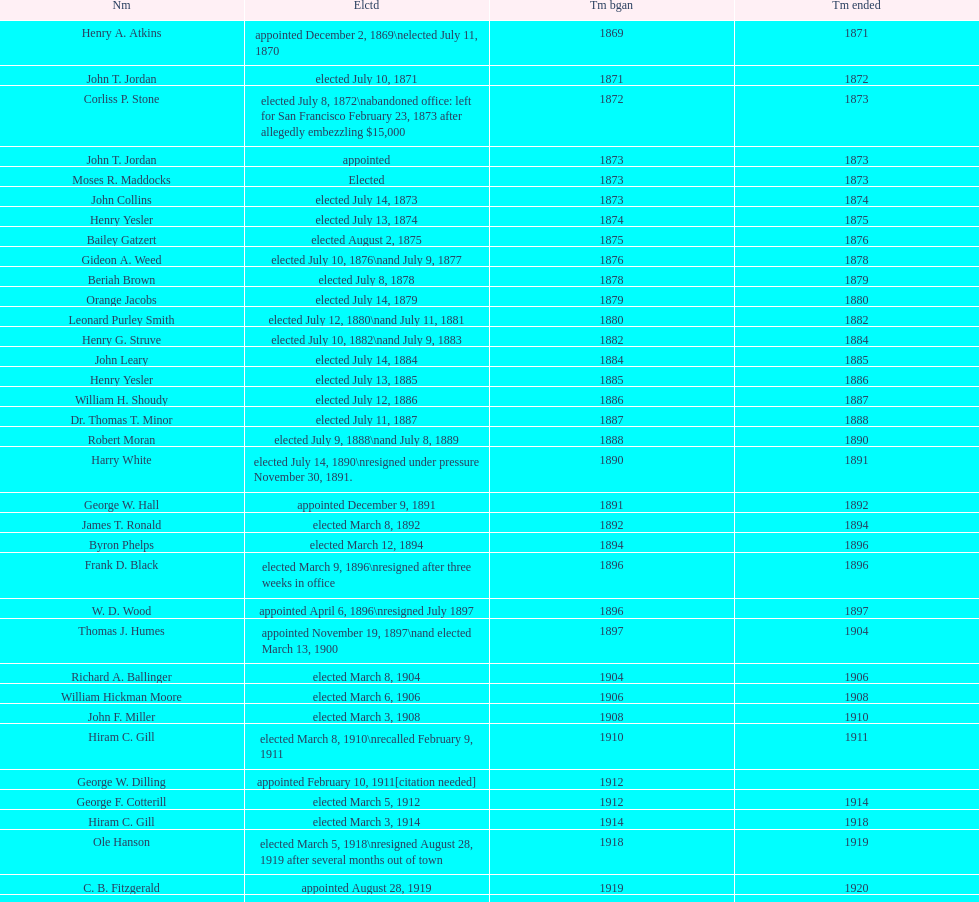Which mayor seattle, washington resigned after only three weeks in office in 1896? Frank D. Black. Give me the full table as a dictionary. {'header': ['Nm', 'Elctd', 'Tm bgan', 'Tm ended'], 'rows': [['Henry A. Atkins', 'appointed December 2, 1869\\nelected July 11, 1870', '1869', '1871'], ['John T. Jordan', 'elected July 10, 1871', '1871', '1872'], ['Corliss P. Stone', 'elected July 8, 1872\\nabandoned office: left for San Francisco February 23, 1873 after allegedly embezzling $15,000', '1872', '1873'], ['John T. Jordan', 'appointed', '1873', '1873'], ['Moses R. Maddocks', 'Elected', '1873', '1873'], ['John Collins', 'elected July 14, 1873', '1873', '1874'], ['Henry Yesler', 'elected July 13, 1874', '1874', '1875'], ['Bailey Gatzert', 'elected August 2, 1875', '1875', '1876'], ['Gideon A. Weed', 'elected July 10, 1876\\nand July 9, 1877', '1876', '1878'], ['Beriah Brown', 'elected July 8, 1878', '1878', '1879'], ['Orange Jacobs', 'elected July 14, 1879', '1879', '1880'], ['Leonard Purley Smith', 'elected July 12, 1880\\nand July 11, 1881', '1880', '1882'], ['Henry G. Struve', 'elected July 10, 1882\\nand July 9, 1883', '1882', '1884'], ['John Leary', 'elected July 14, 1884', '1884', '1885'], ['Henry Yesler', 'elected July 13, 1885', '1885', '1886'], ['William H. Shoudy', 'elected July 12, 1886', '1886', '1887'], ['Dr. Thomas T. Minor', 'elected July 11, 1887', '1887', '1888'], ['Robert Moran', 'elected July 9, 1888\\nand July 8, 1889', '1888', '1890'], ['Harry White', 'elected July 14, 1890\\nresigned under pressure November 30, 1891.', '1890', '1891'], ['George W. Hall', 'appointed December 9, 1891', '1891', '1892'], ['James T. Ronald', 'elected March 8, 1892', '1892', '1894'], ['Byron Phelps', 'elected March 12, 1894', '1894', '1896'], ['Frank D. Black', 'elected March 9, 1896\\nresigned after three weeks in office', '1896', '1896'], ['W. D. Wood', 'appointed April 6, 1896\\nresigned July 1897', '1896', '1897'], ['Thomas J. Humes', 'appointed November 19, 1897\\nand elected March 13, 1900', '1897', '1904'], ['Richard A. Ballinger', 'elected March 8, 1904', '1904', '1906'], ['William Hickman Moore', 'elected March 6, 1906', '1906', '1908'], ['John F. Miller', 'elected March 3, 1908', '1908', '1910'], ['Hiram C. Gill', 'elected March 8, 1910\\nrecalled February 9, 1911', '1910', '1911'], ['George W. Dilling', 'appointed February 10, 1911[citation needed]', '1912', ''], ['George F. Cotterill', 'elected March 5, 1912', '1912', '1914'], ['Hiram C. Gill', 'elected March 3, 1914', '1914', '1918'], ['Ole Hanson', 'elected March 5, 1918\\nresigned August 28, 1919 after several months out of town', '1918', '1919'], ['C. B. Fitzgerald', 'appointed August 28, 1919', '1919', '1920'], ['Hugh M. Caldwell', 'elected March 2, 1920', '1920', '1922'], ['Edwin J. Brown', 'elected May 2, 1922\\nand March 4, 1924', '1922', '1926'], ['Bertha Knight Landes', 'elected March 9, 1926', '1926', '1928'], ['Frank E. Edwards', 'elected March 6, 1928\\nand March 4, 1930\\nrecalled July 13, 1931', '1928', '1931'], ['Robert H. Harlin', 'appointed July 14, 1931', '1931', '1932'], ['John F. Dore', 'elected March 8, 1932', '1932', '1934'], ['Charles L. Smith', 'elected March 6, 1934', '1934', '1936'], ['John F. Dore', 'elected March 3, 1936\\nbecame gravely ill and was relieved of office April 13, 1938, already a lame duck after the 1938 election. He died five days later.', '1936', '1938'], ['Arthur B. Langlie', "elected March 8, 1938\\nappointed to take office early, April 27, 1938, after Dore's death.\\nelected March 5, 1940\\nresigned January 11, 1941, to become Governor of Washington", '1938', '1941'], ['John E. Carroll', 'appointed January 27, 1941', '1941', '1941'], ['Earl Millikin', 'elected March 4, 1941', '1941', '1942'], ['William F. Devin', 'elected March 3, 1942, March 7, 1944, March 5, 1946, and March 2, 1948', '1942', '1952'], ['Allan Pomeroy', 'elected March 4, 1952', '1952', '1956'], ['Gordon S. Clinton', 'elected March 6, 1956\\nand March 8, 1960', '1956', '1964'], ["James d'Orma Braman", 'elected March 10, 1964\\nresigned March 23, 1969, to accept an appointment as an Assistant Secretary in the Department of Transportation in the Nixon administration.', '1964', '1969'], ['Floyd C. Miller', 'appointed March 23, 1969', '1969', '1969'], ['Wesley C. Uhlman', 'elected November 4, 1969\\nand November 6, 1973\\nsurvived recall attempt on July 1, 1975', 'December 1, 1969', 'January 1, 1978'], ['Charles Royer', 'elected November 8, 1977, November 3, 1981, and November 5, 1985', 'January 1, 1978', 'January 1, 1990'], ['Norman B. Rice', 'elected November 7, 1989', 'January 1, 1990', 'January 1, 1998'], ['Paul Schell', 'elected November 4, 1997', 'January 1, 1998', 'January 1, 2002'], ['Gregory J. Nickels', 'elected November 6, 2001\\nand November 8, 2005', 'January 1, 2002', 'January 1, 2010'], ['Michael McGinn', 'elected November 3, 2009', 'January 1, 2010', 'January 1, 2014'], ['Ed Murray', 'elected November 5, 2013', 'January 1, 2014', 'present']]} 